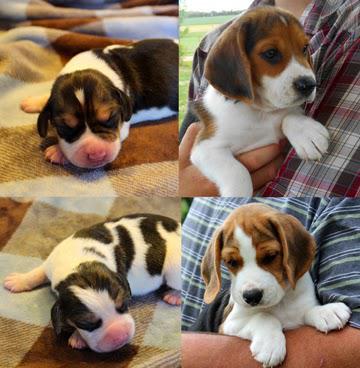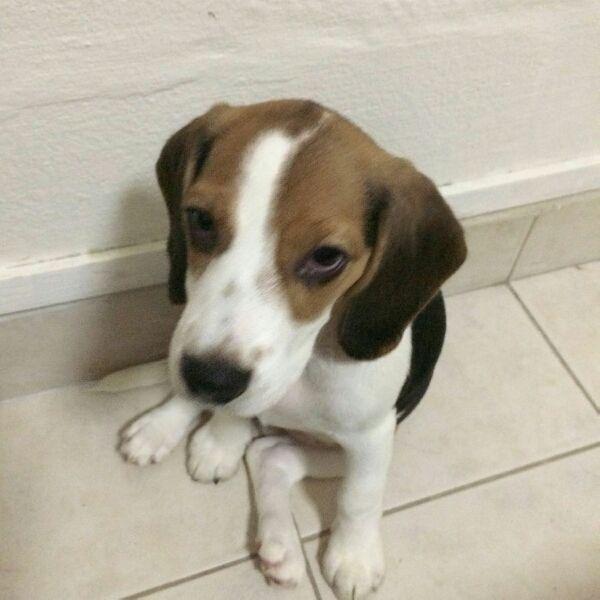The first image is the image on the left, the second image is the image on the right. Given the left and right images, does the statement "The dog on the right is photographed in snow and has a white line going upwards from his nose to his forehead." hold true? Answer yes or no. No. The first image is the image on the left, the second image is the image on the right. For the images displayed, is the sentence "Each image shows exactly one beagle, but the beagle on the right is older with a longer muzzle and is posed on an outdoor surface." factually correct? Answer yes or no. No. 